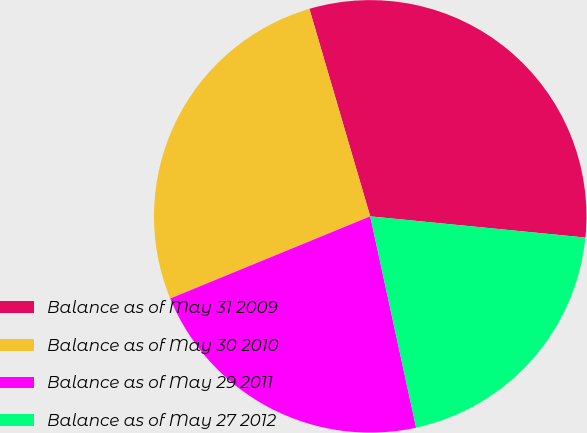Convert chart to OTSL. <chart><loc_0><loc_0><loc_500><loc_500><pie_chart><fcel>Balance as of May 31 2009<fcel>Balance as of May 30 2010<fcel>Balance as of May 29 2011<fcel>Balance as of May 27 2012<nl><fcel>31.1%<fcel>26.66%<fcel>22.2%<fcel>20.03%<nl></chart> 